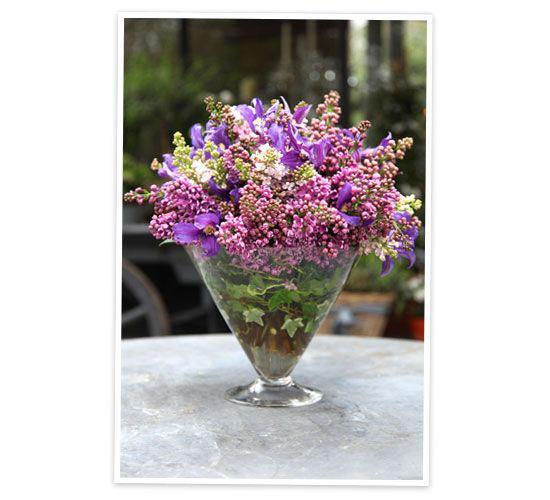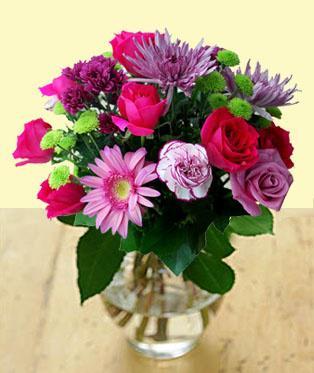The first image is the image on the left, the second image is the image on the right. Examine the images to the left and right. Is the description "One of the vases is purple." accurate? Answer yes or no. No. 